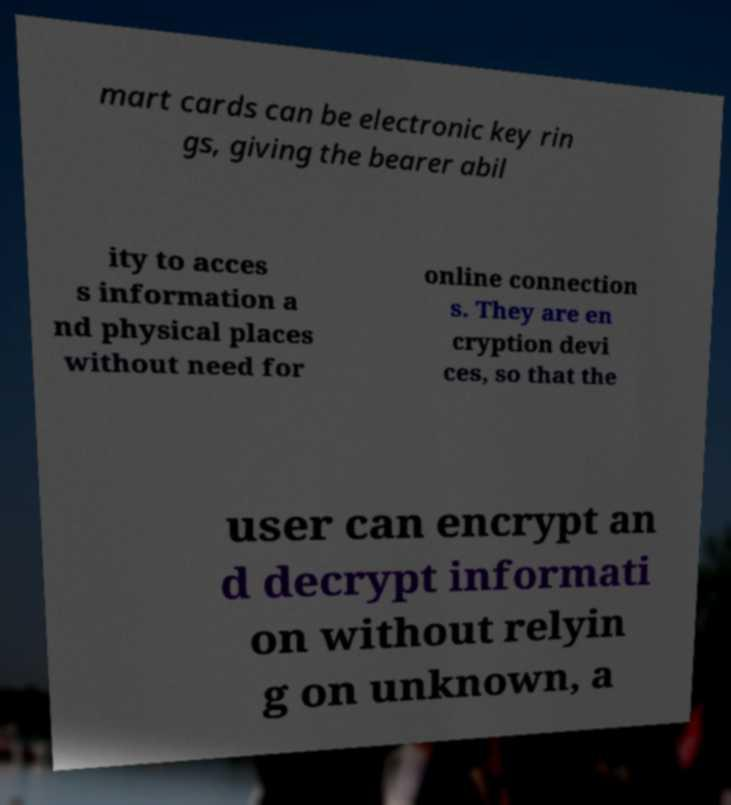Could you assist in decoding the text presented in this image and type it out clearly? mart cards can be electronic key rin gs, giving the bearer abil ity to acces s information a nd physical places without need for online connection s. They are en cryption devi ces, so that the user can encrypt an d decrypt informati on without relyin g on unknown, a 